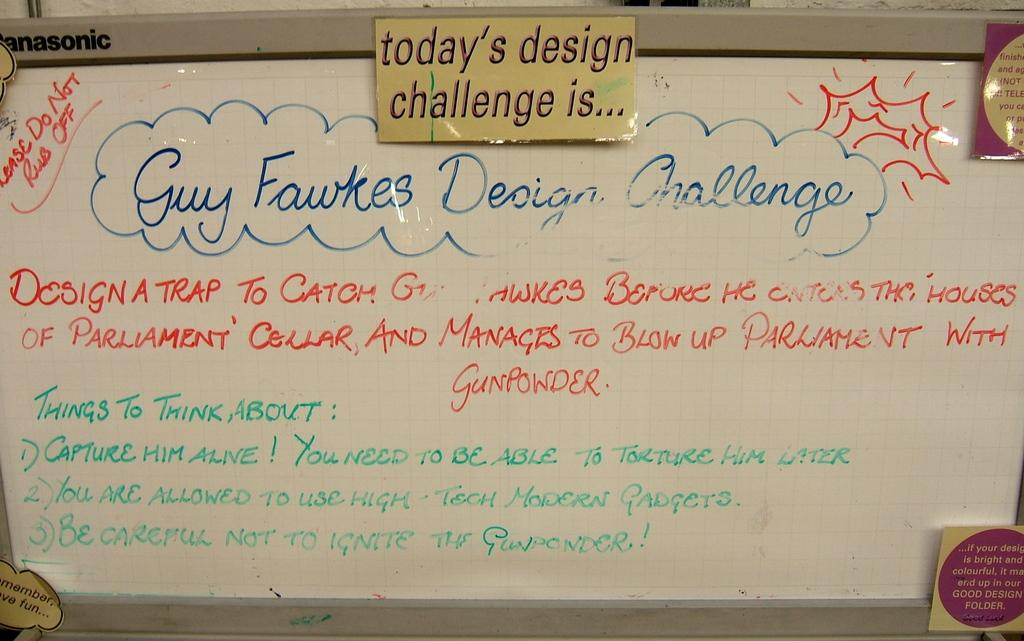What is the main object in the image? There is a whiteboard in the image. What is on the whiteboard? Something is written on the whiteboard. Are there any other objects related to the whiteboard in the image? Yes, there are small boards present in the image. What type of clouds can be seen in the image? There are no clouds present in the image; it features a whiteboard with something written on it and small boards. 